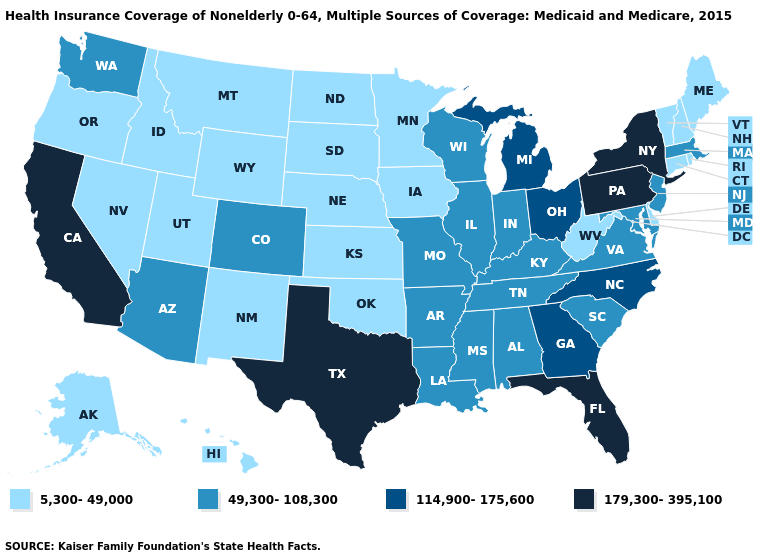Among the states that border California , which have the highest value?
Short answer required. Arizona. Does the first symbol in the legend represent the smallest category?
Keep it brief. Yes. What is the lowest value in the MidWest?
Write a very short answer. 5,300-49,000. How many symbols are there in the legend?
Concise answer only. 4. Name the states that have a value in the range 5,300-49,000?
Concise answer only. Alaska, Connecticut, Delaware, Hawaii, Idaho, Iowa, Kansas, Maine, Minnesota, Montana, Nebraska, Nevada, New Hampshire, New Mexico, North Dakota, Oklahoma, Oregon, Rhode Island, South Dakota, Utah, Vermont, West Virginia, Wyoming. Among the states that border New Mexico , does Oklahoma have the lowest value?
Be succinct. Yes. Is the legend a continuous bar?
Short answer required. No. Name the states that have a value in the range 49,300-108,300?
Quick response, please. Alabama, Arizona, Arkansas, Colorado, Illinois, Indiana, Kentucky, Louisiana, Maryland, Massachusetts, Mississippi, Missouri, New Jersey, South Carolina, Tennessee, Virginia, Washington, Wisconsin. What is the value of Louisiana?
Be succinct. 49,300-108,300. Does Connecticut have a lower value than Oregon?
Answer briefly. No. Name the states that have a value in the range 179,300-395,100?
Keep it brief. California, Florida, New York, Pennsylvania, Texas. Does Tennessee have the same value as Kentucky?
Short answer required. Yes. Among the states that border Wisconsin , which have the highest value?
Concise answer only. Michigan. Name the states that have a value in the range 5,300-49,000?
Give a very brief answer. Alaska, Connecticut, Delaware, Hawaii, Idaho, Iowa, Kansas, Maine, Minnesota, Montana, Nebraska, Nevada, New Hampshire, New Mexico, North Dakota, Oklahoma, Oregon, Rhode Island, South Dakota, Utah, Vermont, West Virginia, Wyoming. Among the states that border Iowa , does Missouri have the lowest value?
Concise answer only. No. 